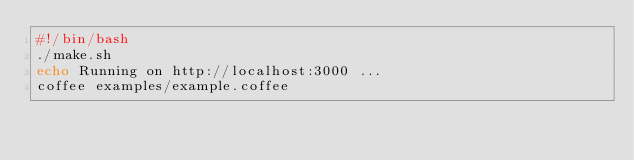<code> <loc_0><loc_0><loc_500><loc_500><_Bash_>#!/bin/bash
./make.sh
echo Running on http://localhost:3000 ...
coffee examples/example.coffee
</code> 